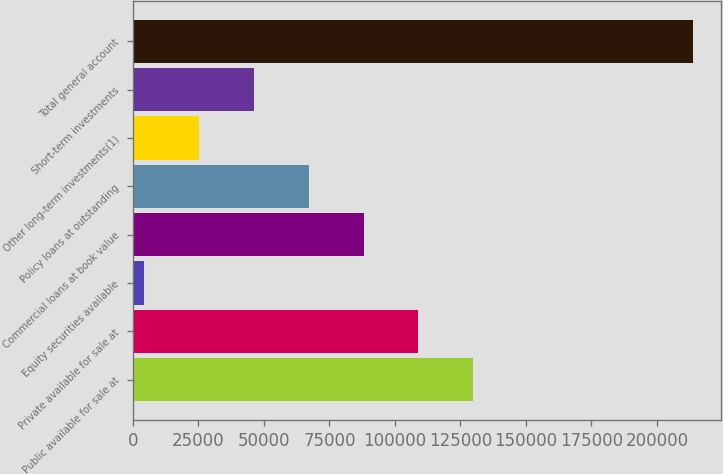Convert chart. <chart><loc_0><loc_0><loc_500><loc_500><bar_chart><fcel>Public available for sale at<fcel>Private available for sale at<fcel>Equity securities available<fcel>Commercial loans at book value<fcel>Policy loans at outstanding<fcel>Other long-term investments(1)<fcel>Short-term investments<fcel>Total general account<nl><fcel>129911<fcel>108971<fcel>4269<fcel>88030.6<fcel>67090.2<fcel>25209.4<fcel>46149.8<fcel>213673<nl></chart> 